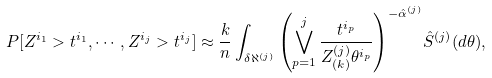<formula> <loc_0><loc_0><loc_500><loc_500>P [ Z ^ { i _ { 1 } } > t ^ { i _ { 1 } } , \cdots , Z ^ { i _ { j } } > t ^ { i _ { j } } ] \approx \frac { k } { n } \int _ { \delta \aleph ^ { ( j ) } } { \left ( \bigvee _ { p = 1 } ^ { j } \frac { t ^ { i _ { p } } } { Z ^ { ( j ) } _ { ( k ) } { \theta } ^ { i _ { p } } } \right ) } ^ { - \hat { \alpha } ^ { ( j ) } } \hat { S } ^ { ( j ) } ( d { \theta } ) ,</formula> 